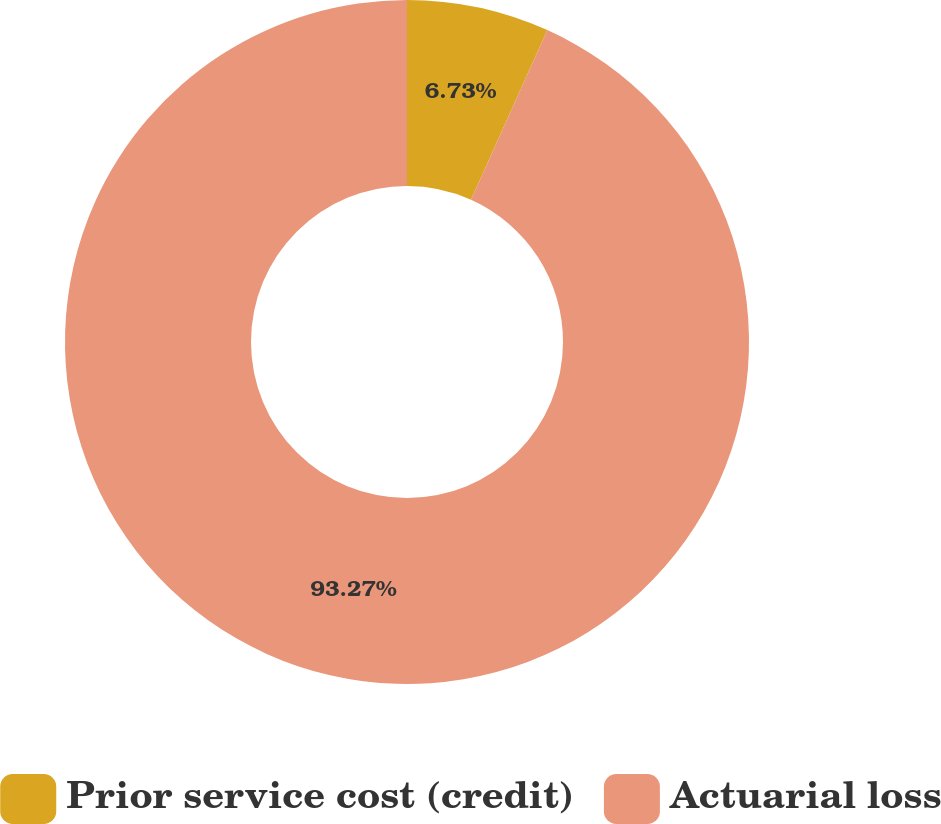<chart> <loc_0><loc_0><loc_500><loc_500><pie_chart><fcel>Prior service cost (credit)<fcel>Actuarial loss<nl><fcel>6.73%<fcel>93.27%<nl></chart> 